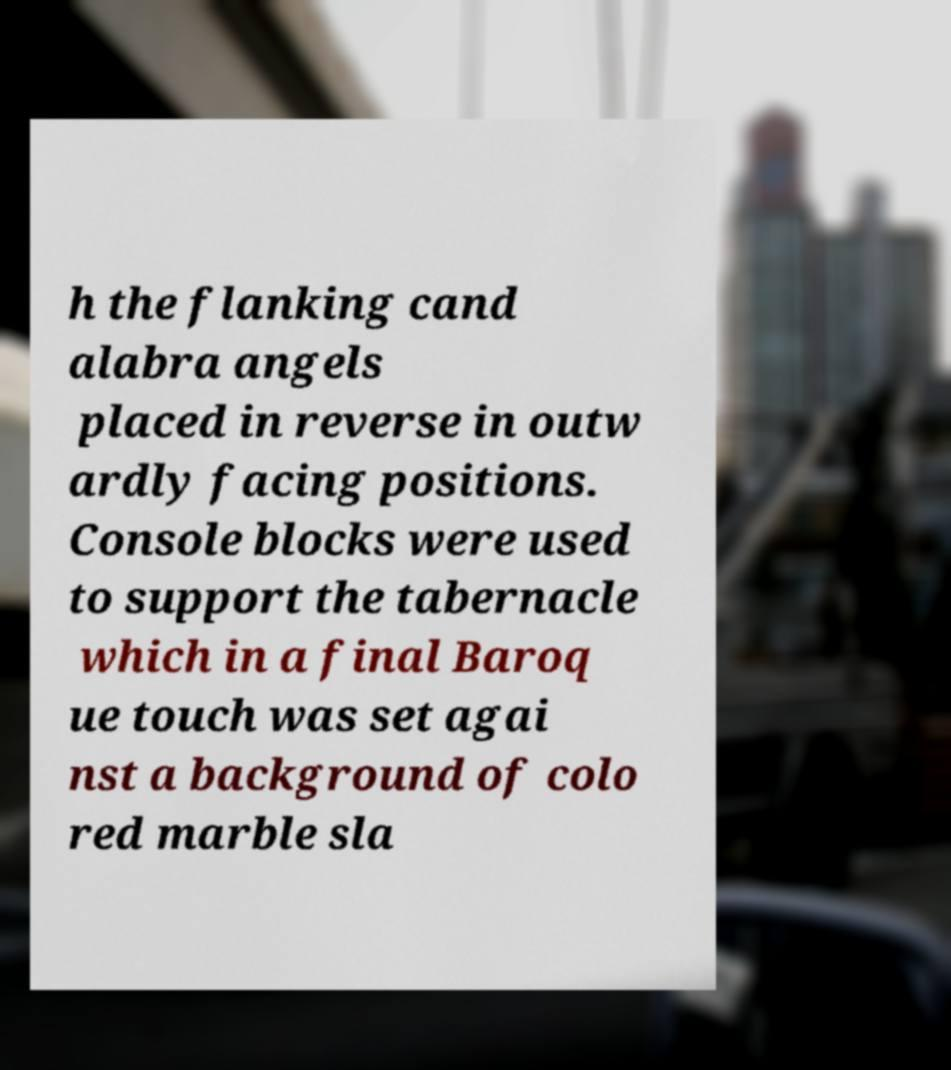Could you assist in decoding the text presented in this image and type it out clearly? h the flanking cand alabra angels placed in reverse in outw ardly facing positions. Console blocks were used to support the tabernacle which in a final Baroq ue touch was set agai nst a background of colo red marble sla 